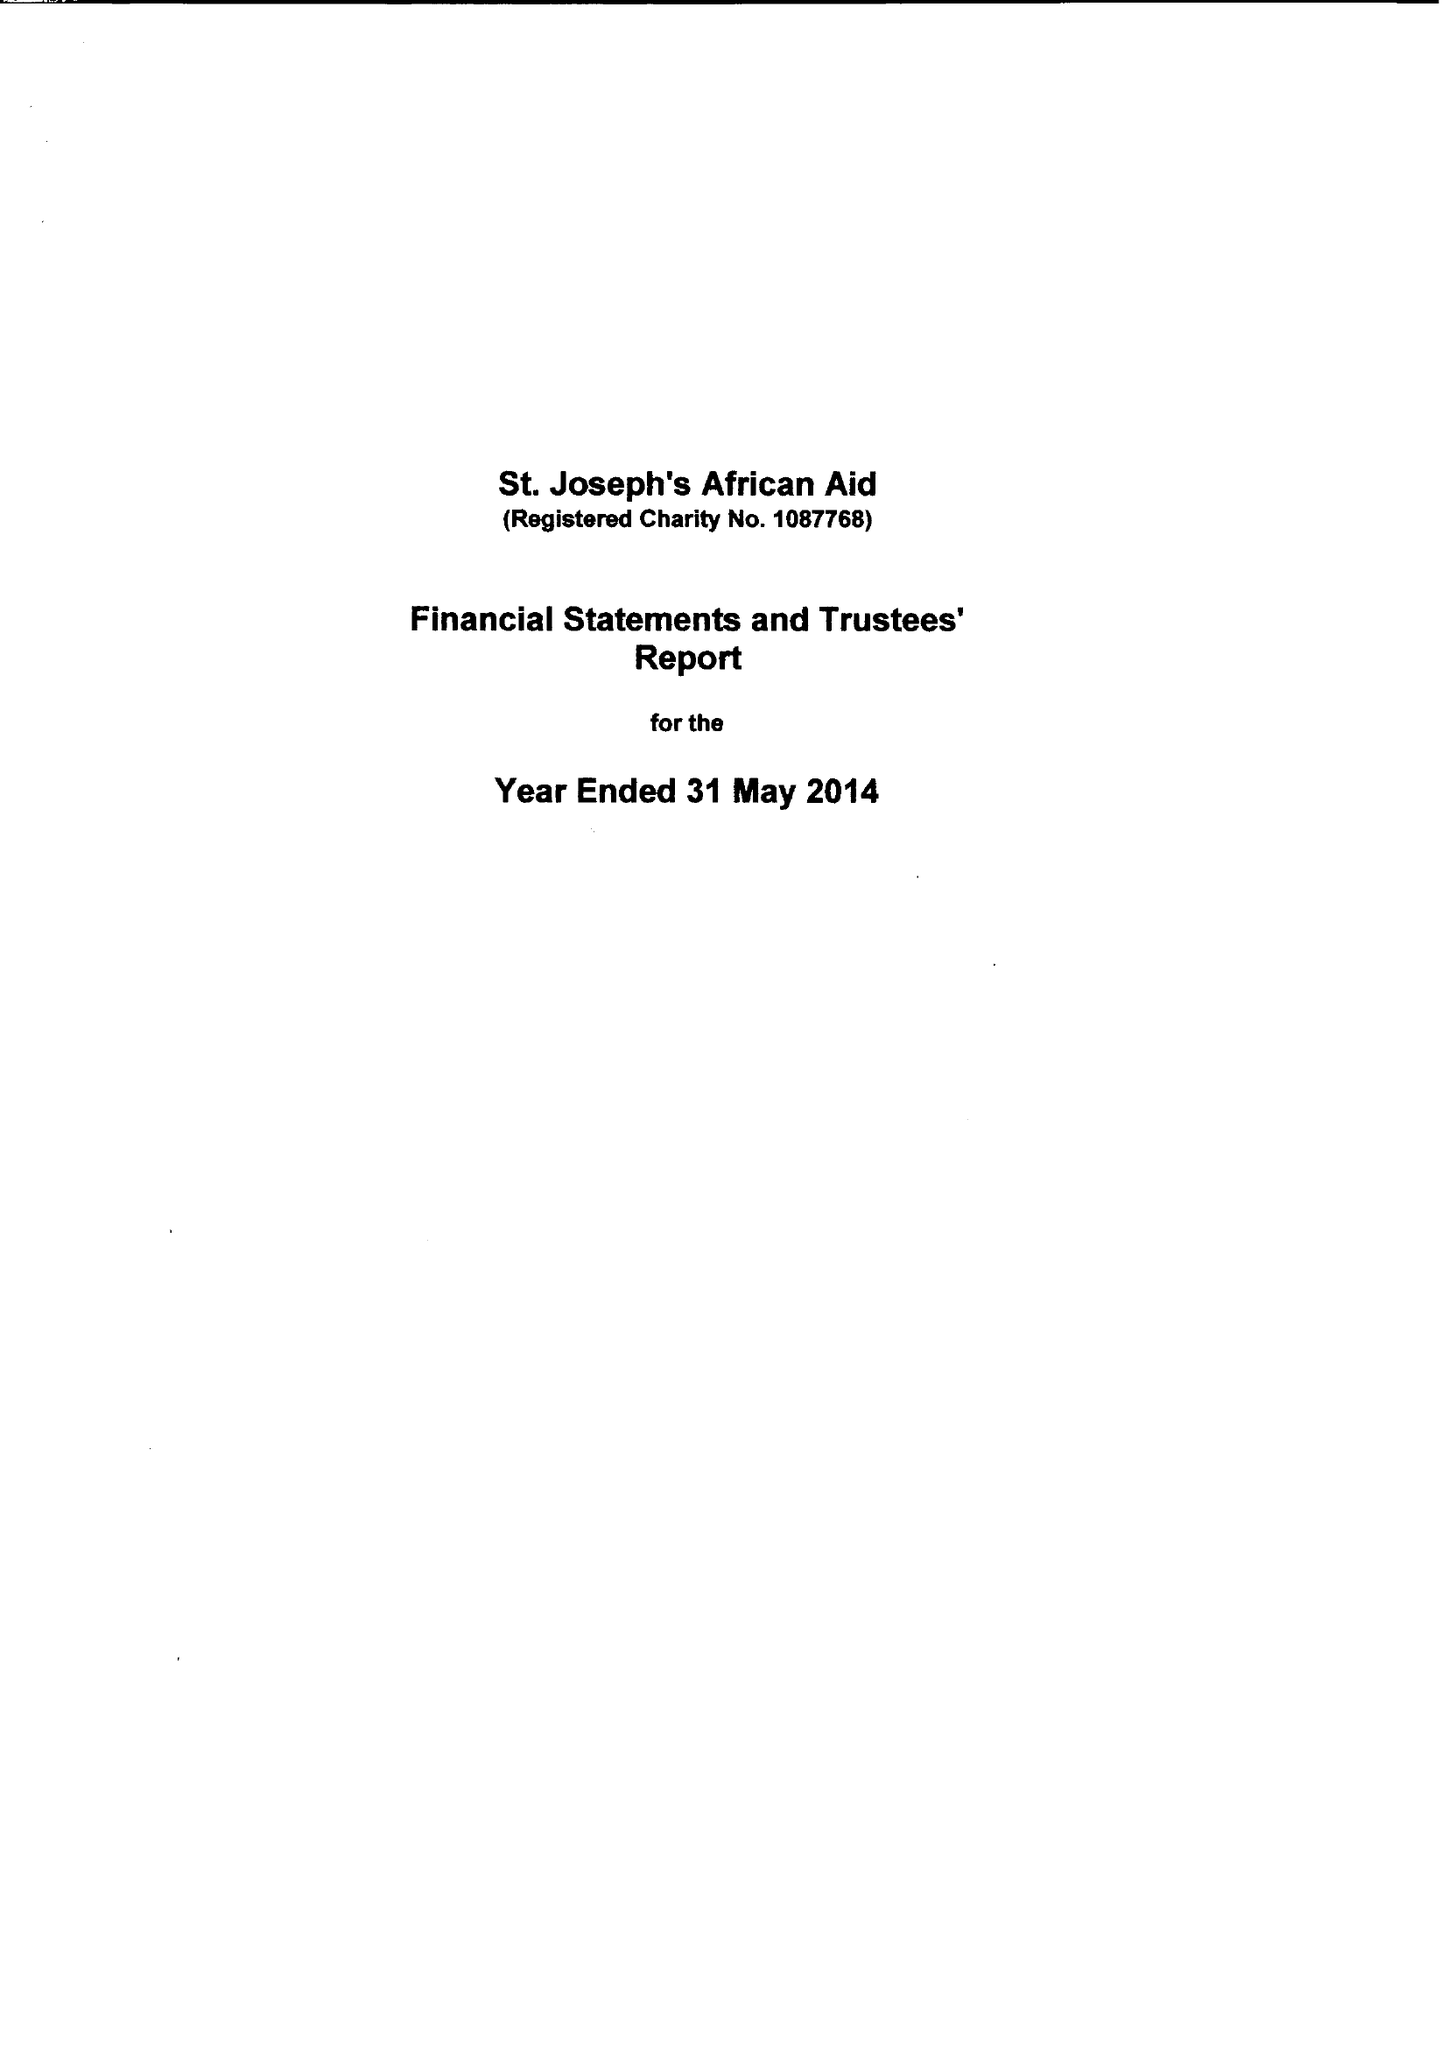What is the value for the charity_number?
Answer the question using a single word or phrase. 1087768 